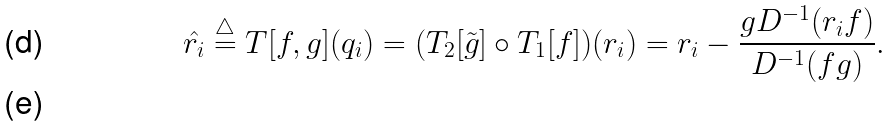Convert formula to latex. <formula><loc_0><loc_0><loc_500><loc_500>\hat { r _ { i } } \stackrel { \triangle } { = } T [ f , g ] ( q _ { i } ) = ( T _ { 2 } [ \tilde { g } ] \circ T _ { 1 } [ f ] ) ( r _ { i } ) = r _ { i } - \frac { g D ^ { - 1 } ( r _ { i } f ) } { D ^ { - 1 } ( f g ) } . \\</formula> 